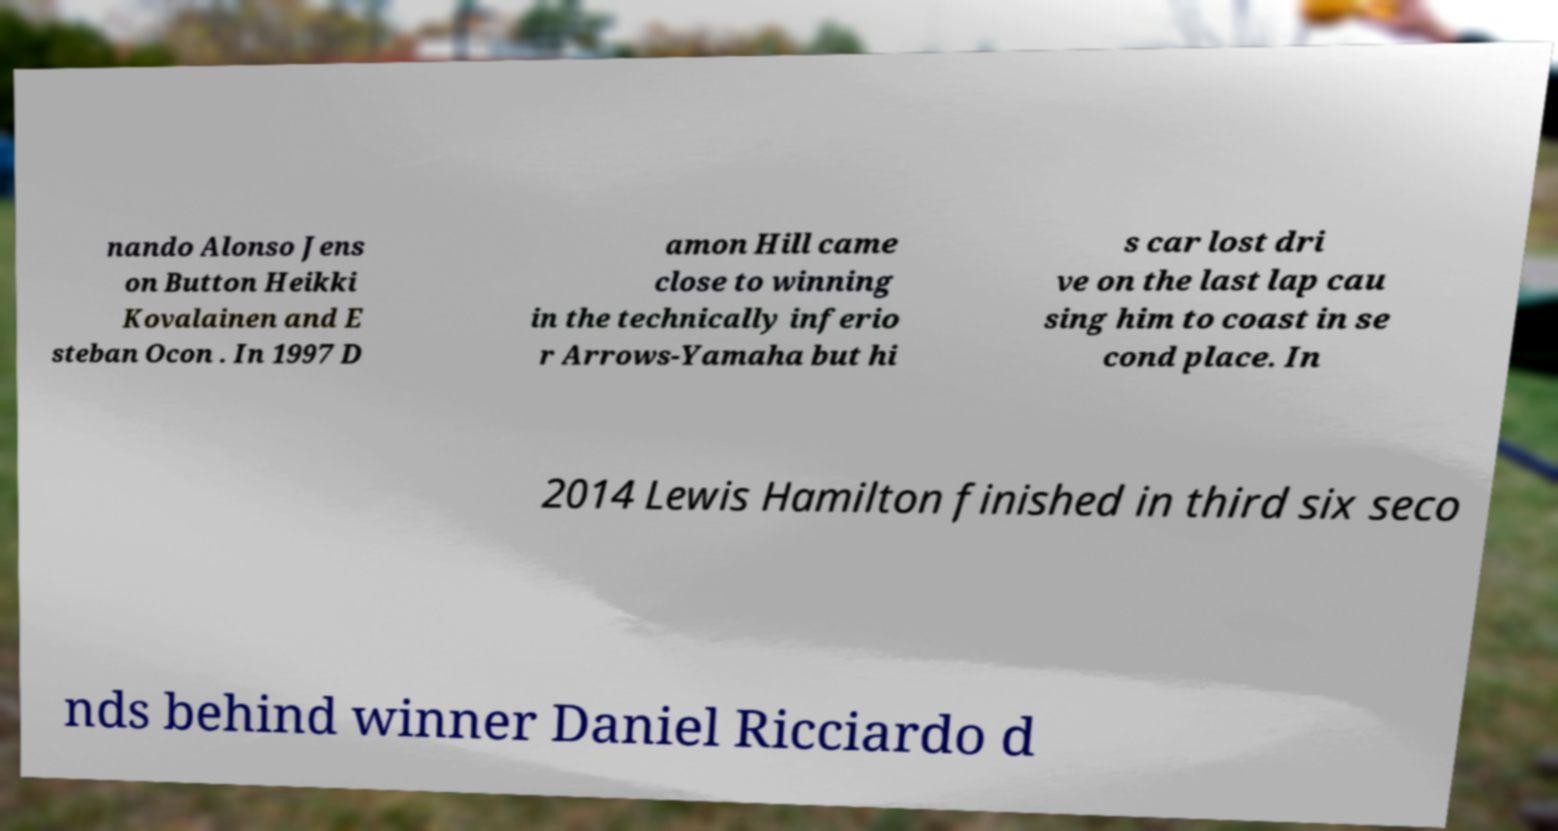I need the written content from this picture converted into text. Can you do that? nando Alonso Jens on Button Heikki Kovalainen and E steban Ocon . In 1997 D amon Hill came close to winning in the technically inferio r Arrows-Yamaha but hi s car lost dri ve on the last lap cau sing him to coast in se cond place. In 2014 Lewis Hamilton finished in third six seco nds behind winner Daniel Ricciardo d 